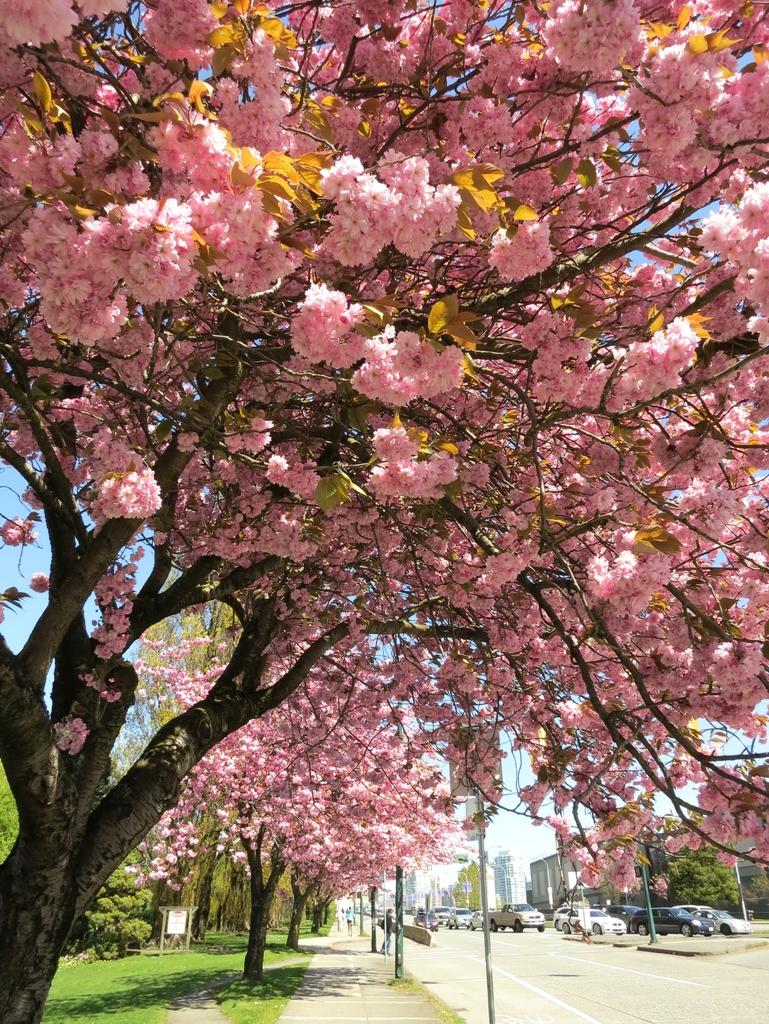What type of vegetation can be seen in the image? There are trees and grass in the image. What structures are present in the image? There are poles, vehicles, a road, buildings, and trees in the image. What is visible behind the trees? The sky is visible behind the trees. Can you tell me how many basketballs are visible in the image? There are no basketballs present in the image. What type of teeth can be seen in the frame of the image? There is no frame or teeth present in the image. 